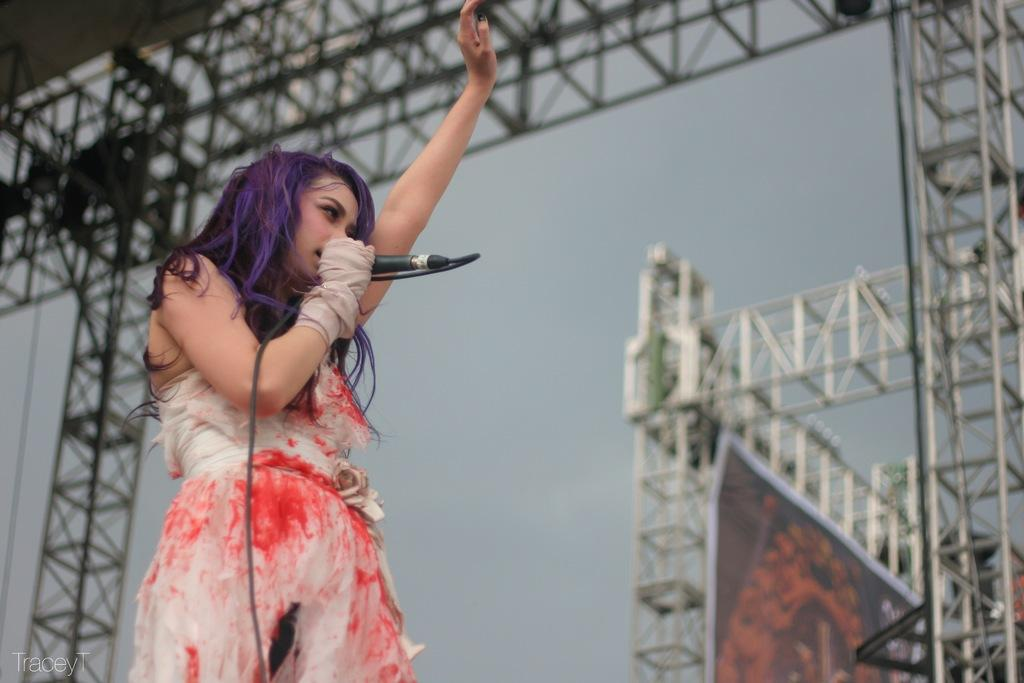Who is the main subject in the picture? There is a girl in the picture. What is the girl doing in the picture? The girl is standing in the picture. What is the girl holding in the picture? The girl is holding a mic in the picture. What type of cake is the girl feeding to the monkey in the picture? There is no cake or monkey present in the image; the girl is holding a mic. 